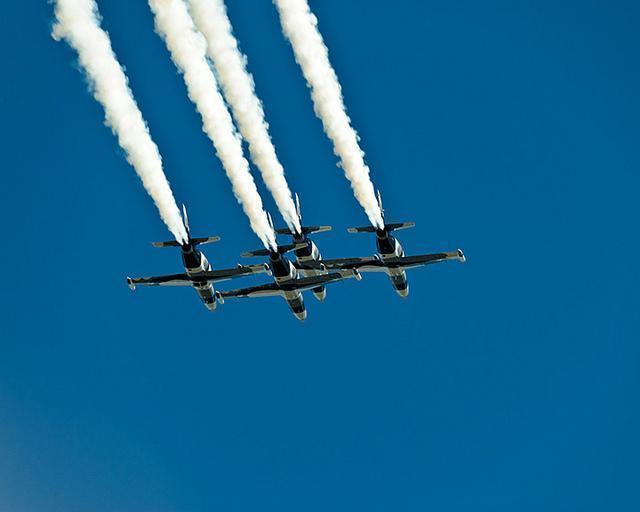How many jet planes are flying together in the sky with military formation?
Select the correct answer and articulate reasoning with the following format: 'Answer: answer
Rationale: rationale.'
Options: One, three, two, four. Answer: four.
Rationale: There are three layers. there is one plane in the top layer, two in the middle layer, and one in the bottom layer. 